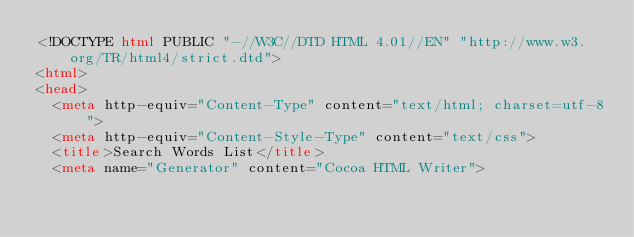<code> <loc_0><loc_0><loc_500><loc_500><_HTML_><!DOCTYPE html PUBLIC "-//W3C//DTD HTML 4.01//EN" "http://www.w3.org/TR/html4/strict.dtd">
<html>
<head>
  <meta http-equiv="Content-Type" content="text/html; charset=utf-8">
  <meta http-equiv="Content-Style-Type" content="text/css">
  <title>Search Words List</title>
  <meta name="Generator" content="Cocoa HTML Writer"></code> 